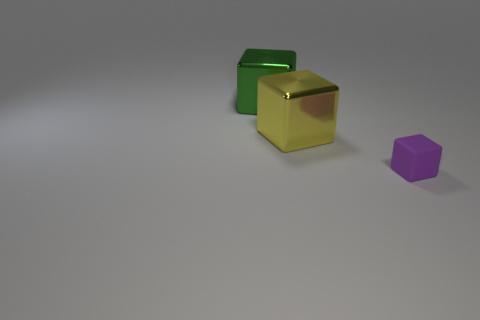Is there anything else that has the same size as the purple block?
Your answer should be compact. No. There is a thing that is in front of the yellow shiny cube on the right side of the green shiny cube; what shape is it?
Ensure brevity in your answer.  Cube. There is a shiny thing behind the big yellow object; how many metal objects are in front of it?
Keep it short and to the point. 1. There is a small purple thing that is the same shape as the large yellow object; what is it made of?
Make the answer very short. Rubber. How many yellow objects are either shiny things or small rubber things?
Your answer should be very brief. 1. Is there any other thing that is the same color as the tiny matte block?
Offer a very short reply. No. What is the color of the large metal block in front of the big object behind the large yellow shiny cube?
Your answer should be very brief. Yellow. Are there fewer green objects that are in front of the green cube than objects that are on the left side of the small matte cube?
Your answer should be compact. Yes. How many objects are cubes to the left of the purple rubber block or tiny purple shiny cylinders?
Give a very brief answer. 2. Is the size of the thing right of the yellow thing the same as the yellow thing?
Your answer should be compact. No. 